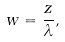<formula> <loc_0><loc_0><loc_500><loc_500>w = \frac { z } { \lambda } ,</formula> 